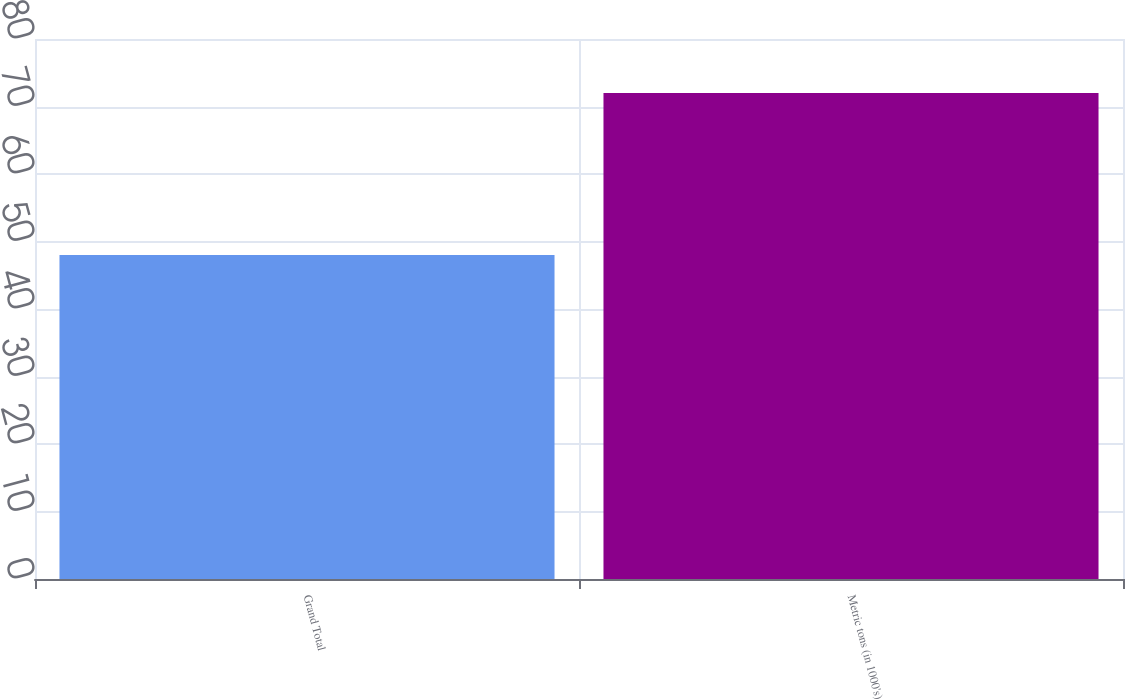Convert chart. <chart><loc_0><loc_0><loc_500><loc_500><bar_chart><fcel>Grand Total<fcel>Metric tons (in 1000's)<nl><fcel>48<fcel>72<nl></chart> 